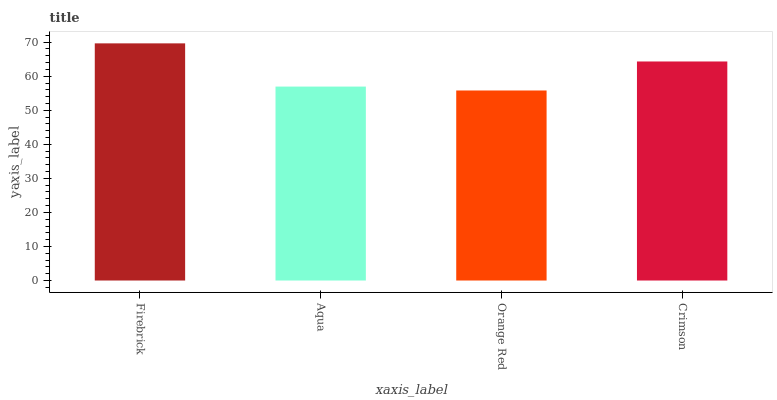Is Orange Red the minimum?
Answer yes or no. Yes. Is Firebrick the maximum?
Answer yes or no. Yes. Is Aqua the minimum?
Answer yes or no. No. Is Aqua the maximum?
Answer yes or no. No. Is Firebrick greater than Aqua?
Answer yes or no. Yes. Is Aqua less than Firebrick?
Answer yes or no. Yes. Is Aqua greater than Firebrick?
Answer yes or no. No. Is Firebrick less than Aqua?
Answer yes or no. No. Is Crimson the high median?
Answer yes or no. Yes. Is Aqua the low median?
Answer yes or no. Yes. Is Orange Red the high median?
Answer yes or no. No. Is Crimson the low median?
Answer yes or no. No. 